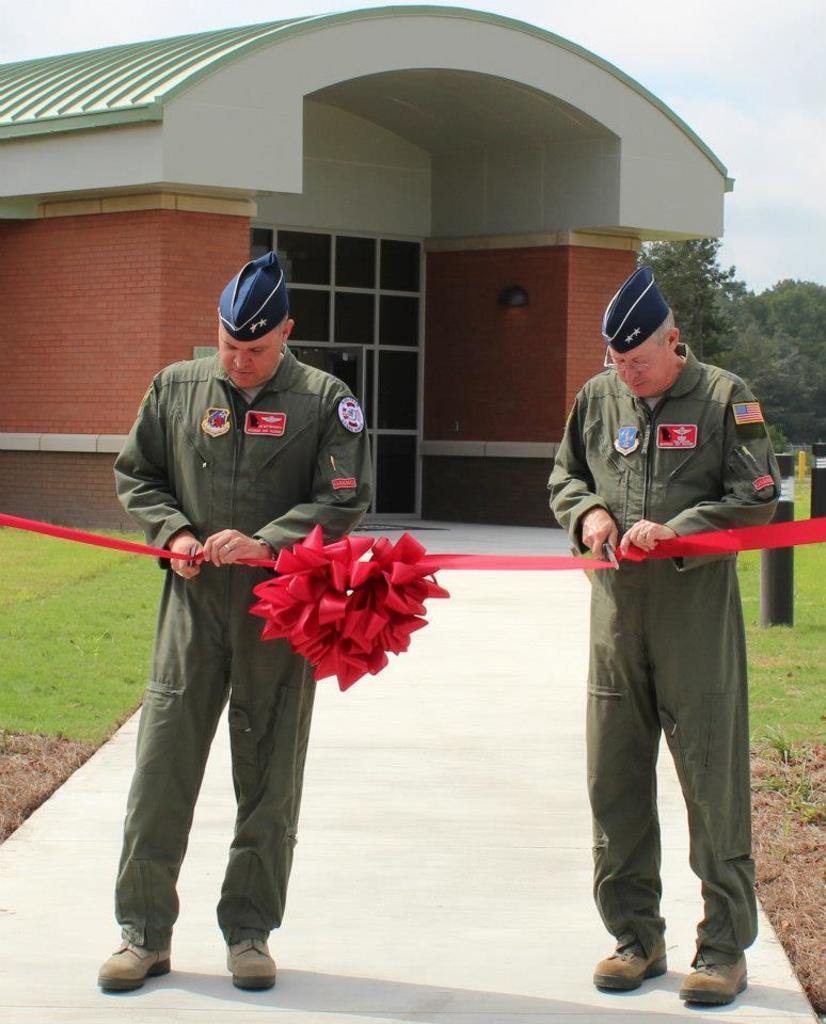Describe this image in one or two sentences. Here we can see two persons are cutting a ribbon. This is grass. In the background we can see a building, trees, and sky. 